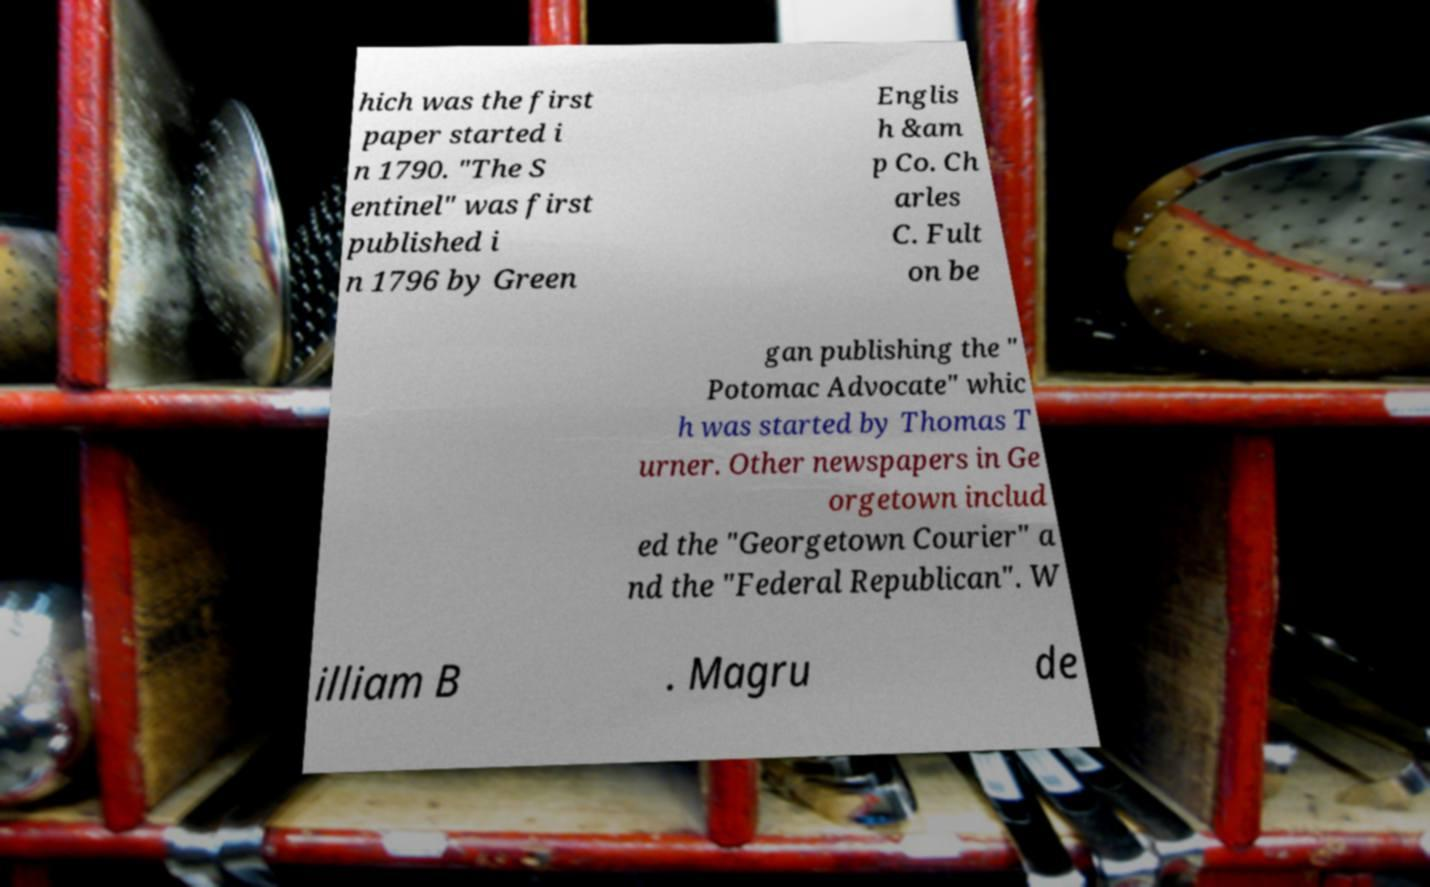Could you extract and type out the text from this image? hich was the first paper started i n 1790. "The S entinel" was first published i n 1796 by Green Englis h &am p Co. Ch arles C. Fult on be gan publishing the " Potomac Advocate" whic h was started by Thomas T urner. Other newspapers in Ge orgetown includ ed the "Georgetown Courier" a nd the "Federal Republican". W illiam B . Magru de 